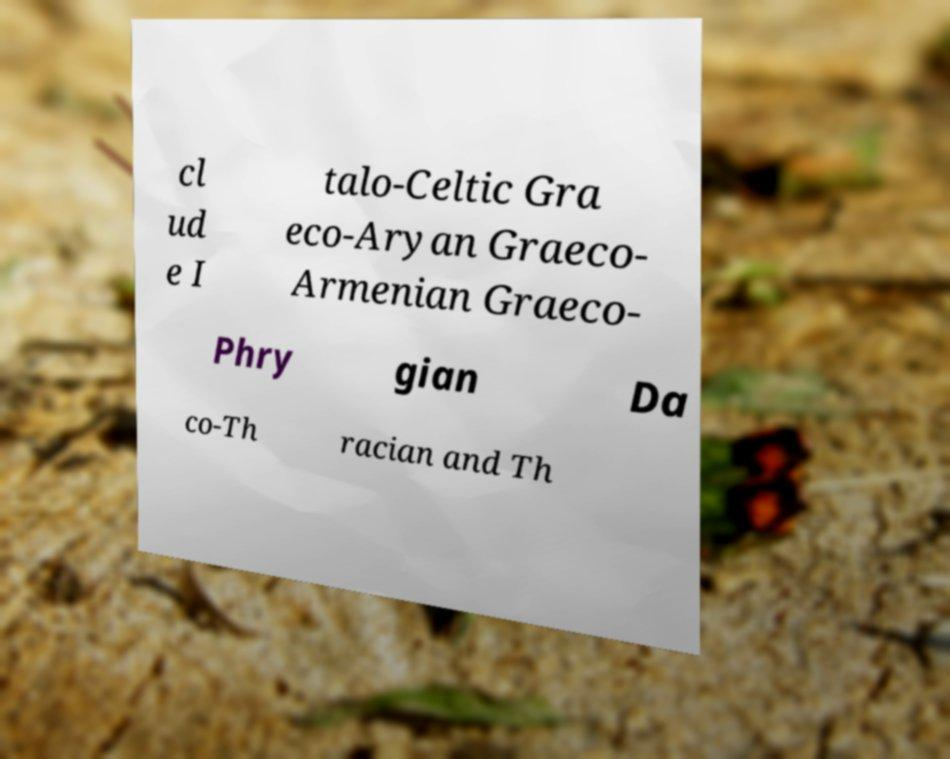Please identify and transcribe the text found in this image. cl ud e I talo-Celtic Gra eco-Aryan Graeco- Armenian Graeco- Phry gian Da co-Th racian and Th 